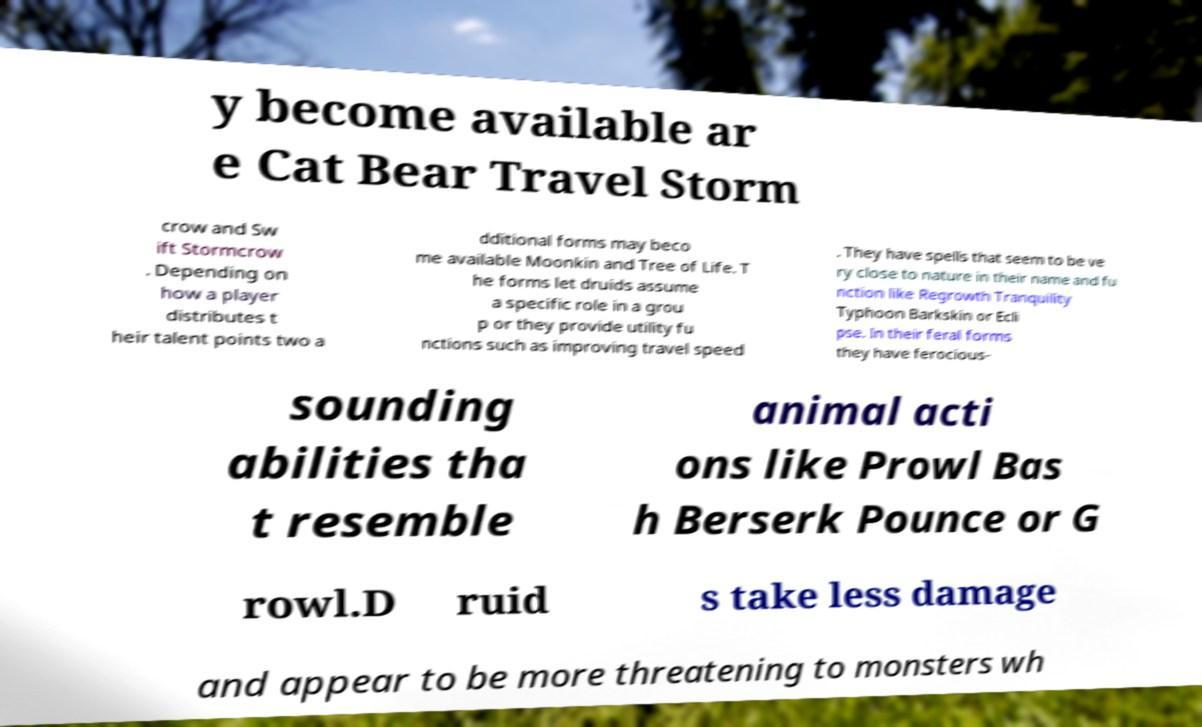For documentation purposes, I need the text within this image transcribed. Could you provide that? y become available ar e Cat Bear Travel Storm crow and Sw ift Stormcrow . Depending on how a player distributes t heir talent points two a dditional forms may beco me available Moonkin and Tree of Life. T he forms let druids assume a specific role in a grou p or they provide utility fu nctions such as improving travel speed . They have spells that seem to be ve ry close to nature in their name and fu nction like Regrowth Tranquility Typhoon Barkskin or Ecli pse. In their feral forms they have ferocious- sounding abilities tha t resemble animal acti ons like Prowl Bas h Berserk Pounce or G rowl.D ruid s take less damage and appear to be more threatening to monsters wh 